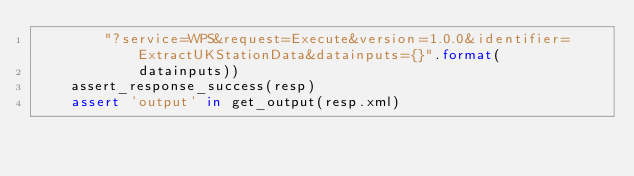<code> <loc_0><loc_0><loc_500><loc_500><_Python_>        "?service=WPS&request=Execute&version=1.0.0&identifier=ExtractUKStationData&datainputs={}".format(
            datainputs))
    assert_response_success(resp)
    assert 'output' in get_output(resp.xml)
</code> 